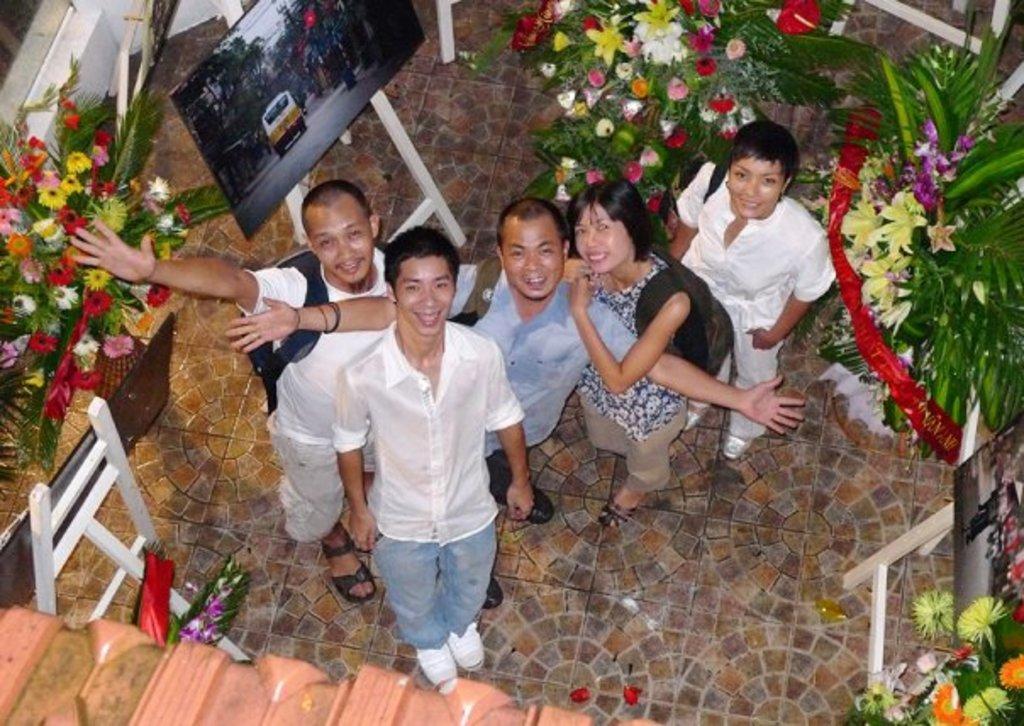In one or two sentences, can you explain what this image depicts? This picture seems to be clicked inside the room. In the center we can see the group of people wearing backpacks, smiling and standing on the ground and we can see a person wearing white color shirt, smiling and standing on the pavement and we can see many numbers of objects are placed on the ground and we can see the green leaves, colorful flowers and we can see the pictures consists of the sky, trees, buildings, vehicles and the people and some other items. 